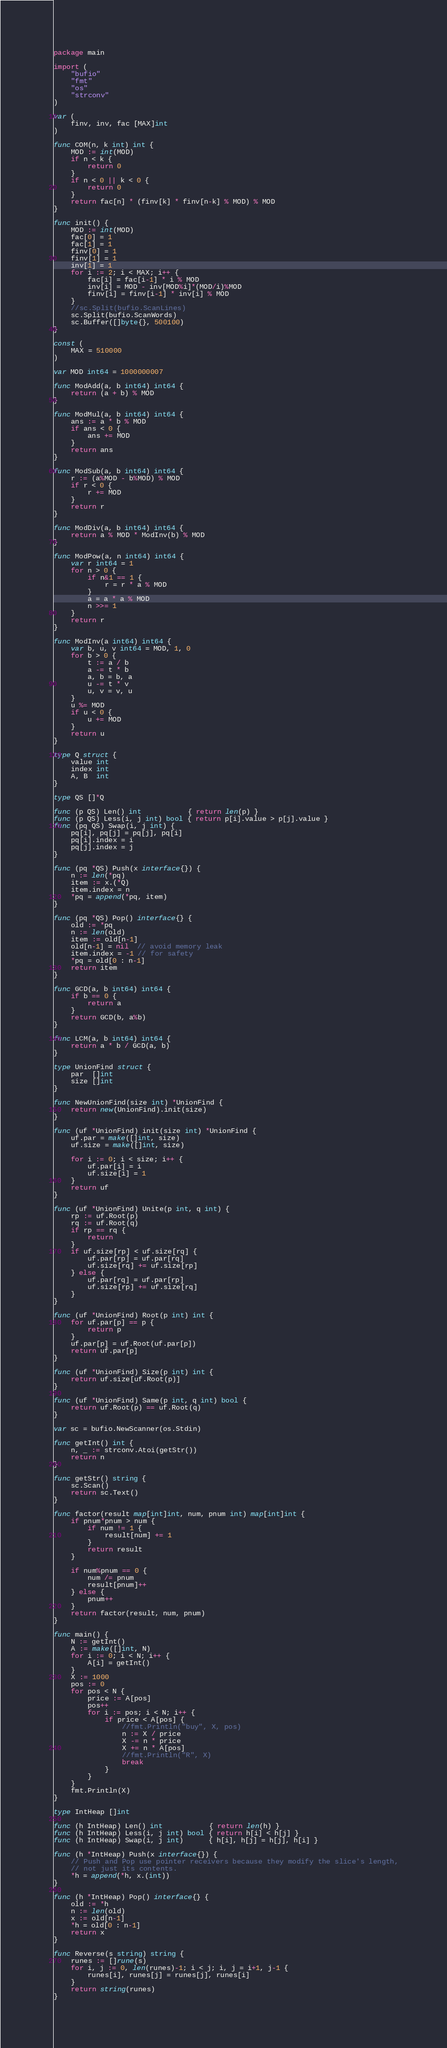<code> <loc_0><loc_0><loc_500><loc_500><_Go_>package main

import (
	"bufio"
	"fmt"
	"os"
	"strconv"
)

var (
	finv, inv, fac [MAX]int
)

func COM(n, k int) int {
	MOD := int(MOD)
	if n < k {
		return 0
	}
	if n < 0 || k < 0 {
		return 0
	}
	return fac[n] * (finv[k] * finv[n-k] % MOD) % MOD
}

func init() {
	MOD := int(MOD)
	fac[0] = 1
	fac[1] = 1
	finv[0] = 1
	finv[1] = 1
	inv[1] = 1
	for i := 2; i < MAX; i++ {
		fac[i] = fac[i-1] * i % MOD
		inv[i] = MOD - inv[MOD%i]*(MOD/i)%MOD
		finv[i] = finv[i-1] * inv[i] % MOD
	}
	//sc.Split(bufio.ScanLines)
	sc.Split(bufio.ScanWords)
	sc.Buffer([]byte{}, 500100)
}

const (
	MAX = 510000
)

var MOD int64 = 1000000007

func ModAdd(a, b int64) int64 {
	return (a + b) % MOD
}

func ModMul(a, b int64) int64 {
	ans := a * b % MOD
	if ans < 0 {
		ans += MOD
	}
	return ans
}

func ModSub(a, b int64) int64 {
	r := (a%MOD - b%MOD) % MOD
	if r < 0 {
		r += MOD
	}
	return r
}

func ModDiv(a, b int64) int64 {
	return a % MOD * ModInv(b) % MOD
}

func ModPow(a, n int64) int64 {
	var r int64 = 1
	for n > 0 {
		if n&1 == 1 {
			r = r * a % MOD
		}
		a = a * a % MOD
		n >>= 1
	}
	return r
}

func ModInv(a int64) int64 {
	var b, u, v int64 = MOD, 1, 0
	for b > 0 {
		t := a / b
		a -= t * b
		a, b = b, a
		u -= t * v
		u, v = v, u
	}
	u %= MOD
	if u < 0 {
		u += MOD
	}
	return u
}

type Q struct {
	value int
	index int
	A, B  int
}

type QS []*Q

func (p QS) Len() int           { return len(p) }
func (p QS) Less(i, j int) bool { return p[i].value > p[j].value }
func (pq QS) Swap(i, j int) {
	pq[i], pq[j] = pq[j], pq[i]
	pq[i].index = i
	pq[j].index = j
}

func (pq *QS) Push(x interface{}) {
	n := len(*pq)
	item := x.(*Q)
	item.index = n
	*pq = append(*pq, item)
}

func (pq *QS) Pop() interface{} {
	old := *pq
	n := len(old)
	item := old[n-1]
	old[n-1] = nil  // avoid memory leak
	item.index = -1 // for safety
	*pq = old[0 : n-1]
	return item
}

func GCD(a, b int64) int64 {
	if b == 0 {
		return a
	}
	return GCD(b, a%b)
}

func LCM(a, b int64) int64 {
	return a * b / GCD(a, b)
}

type UnionFind struct {
	par  []int
	size []int
}

func NewUnionFind(size int) *UnionFind {
	return new(UnionFind).init(size)
}

func (uf *UnionFind) init(size int) *UnionFind {
	uf.par = make([]int, size)
	uf.size = make([]int, size)

	for i := 0; i < size; i++ {
		uf.par[i] = i
		uf.size[i] = 1
	}
	return uf
}

func (uf *UnionFind) Unite(p int, q int) {
	rp := uf.Root(p)
	rq := uf.Root(q)
	if rp == rq {
		return
	}
	if uf.size[rp] < uf.size[rq] {
		uf.par[rp] = uf.par[rq]
		uf.size[rq] += uf.size[rp]
	} else {
		uf.par[rq] = uf.par[rp]
		uf.size[rp] += uf.size[rq]
	}
}

func (uf *UnionFind) Root(p int) int {
	for uf.par[p] == p {
		return p
	}
	uf.par[p] = uf.Root(uf.par[p])
	return uf.par[p]
}

func (uf *UnionFind) Size(p int) int {
	return uf.size[uf.Root(p)]
}

func (uf *UnionFind) Same(p int, q int) bool {
	return uf.Root(p) == uf.Root(q)
}

var sc = bufio.NewScanner(os.Stdin)

func getInt() int {
	n, _ := strconv.Atoi(getStr())
	return n
}

func getStr() string {
	sc.Scan()
	return sc.Text()
}

func factor(result map[int]int, num, pnum int) map[int]int {
	if pnum*pnum > num {
		if num != 1 {
			result[num] += 1
		}
		return result
	}

	if num%pnum == 0 {
		num /= pnum
		result[pnum]++
	} else {
		pnum++
	}
	return factor(result, num, pnum)
}

func main() {
	N := getInt()
	A := make([]int, N)
	for i := 0; i < N; i++ {
		A[i] = getInt()
	}
	X := 1000
	pos := 0
	for pos < N {
		price := A[pos]
		pos++
		for i := pos; i < N; i++ {
			if price < A[pos] {
				//fmt.Println("buy", X, pos)
				n := X / price
				X -= n * price
				X += n * A[pos]
				//fmt.Println("R", X)
				break
			}
		}
	}
	fmt.Println(X)
}

type IntHeap []int

func (h IntHeap) Len() int           { return len(h) }
func (h IntHeap) Less(i, j int) bool { return h[i] < h[j] }
func (h IntHeap) Swap(i, j int)      { h[i], h[j] = h[j], h[i] }

func (h *IntHeap) Push(x interface{}) {
	// Push and Pop use pointer receivers because they modify the slice's length,
	// not just its contents.
	*h = append(*h, x.(int))
}

func (h *IntHeap) Pop() interface{} {
	old := *h
	n := len(old)
	x := old[n-1]
	*h = old[0 : n-1]
	return x
}

func Reverse(s string) string {
	runes := []rune(s)
	for i, j := 0, len(runes)-1; i < j; i, j = i+1, j-1 {
		runes[i], runes[j] = runes[j], runes[i]
	}
	return string(runes)
}
</code> 